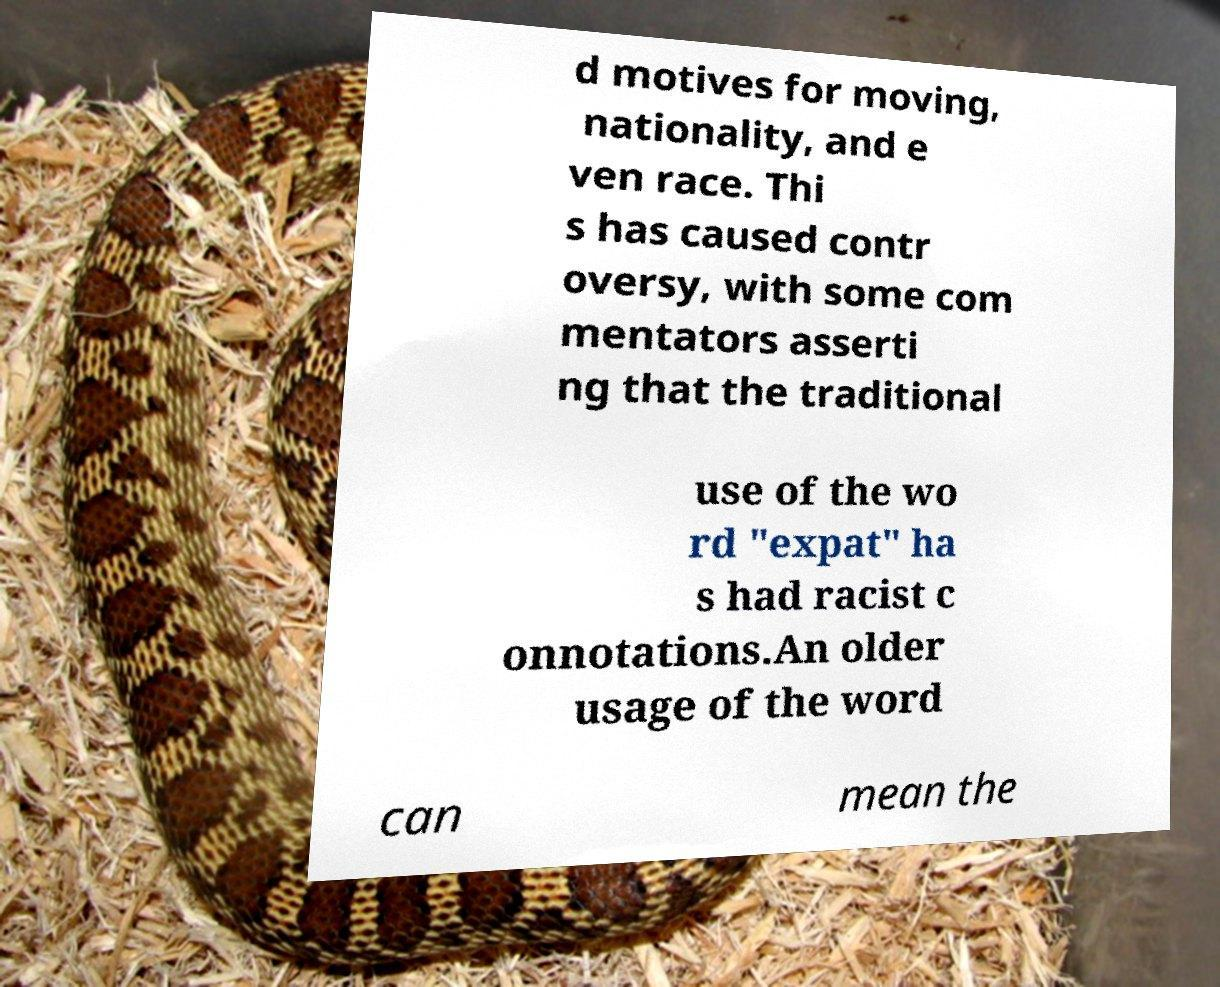I need the written content from this picture converted into text. Can you do that? d motives for moving, nationality, and e ven race. Thi s has caused contr oversy, with some com mentators asserti ng that the traditional use of the wo rd "expat" ha s had racist c onnotations.An older usage of the word can mean the 